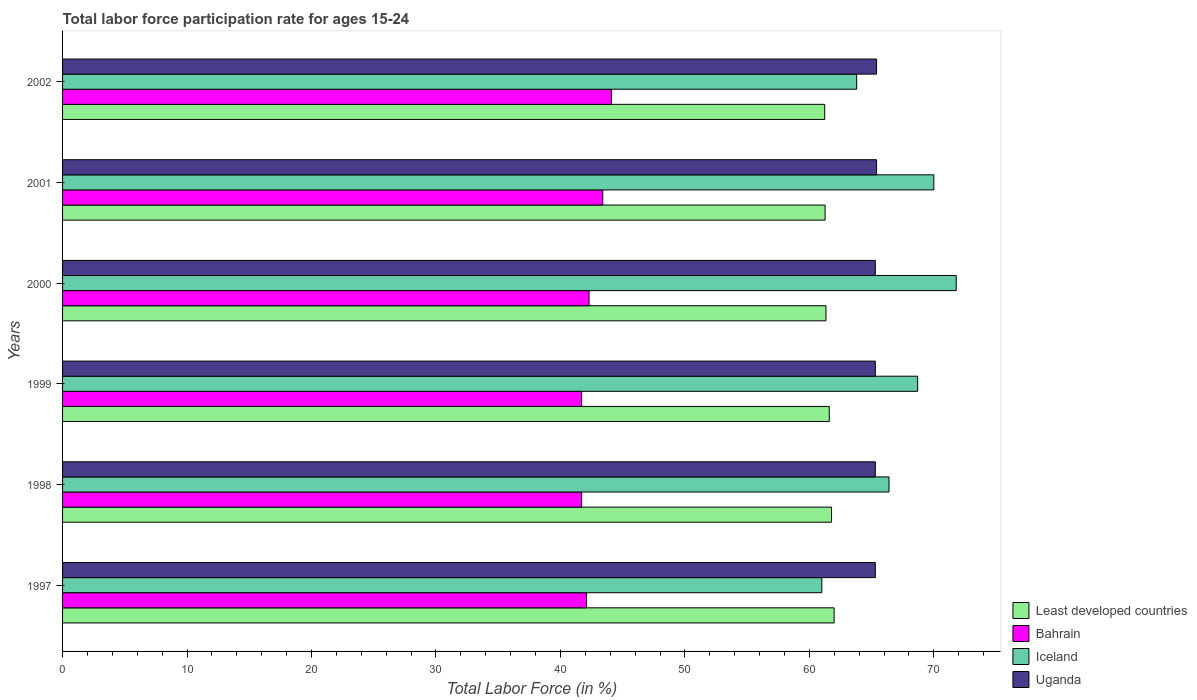How many different coloured bars are there?
Make the answer very short. 4. Are the number of bars on each tick of the Y-axis equal?
Provide a succinct answer. Yes. What is the label of the 4th group of bars from the top?
Give a very brief answer. 1999. What is the labor force participation rate in Iceland in 1999?
Your answer should be very brief. 68.7. Across all years, what is the maximum labor force participation rate in Uganda?
Ensure brevity in your answer.  65.4. Across all years, what is the minimum labor force participation rate in Iceland?
Your response must be concise. 61. In which year was the labor force participation rate in Iceland maximum?
Offer a very short reply. 2000. What is the total labor force participation rate in Iceland in the graph?
Ensure brevity in your answer.  401.7. What is the difference between the labor force participation rate in Least developed countries in 1998 and that in 1999?
Your answer should be compact. 0.18. What is the difference between the labor force participation rate in Iceland in 1997 and the labor force participation rate in Bahrain in 1999?
Offer a very short reply. 19.3. What is the average labor force participation rate in Least developed countries per year?
Provide a succinct answer. 61.53. In the year 2000, what is the difference between the labor force participation rate in Uganda and labor force participation rate in Bahrain?
Offer a terse response. 23. What is the ratio of the labor force participation rate in Iceland in 2001 to that in 2002?
Make the answer very short. 1.1. Is the difference between the labor force participation rate in Uganda in 1999 and 2000 greater than the difference between the labor force participation rate in Bahrain in 1999 and 2000?
Make the answer very short. Yes. What is the difference between the highest and the second highest labor force participation rate in Bahrain?
Offer a terse response. 0.7. What is the difference between the highest and the lowest labor force participation rate in Least developed countries?
Keep it short and to the point. 0.76. Is the sum of the labor force participation rate in Uganda in 2000 and 2002 greater than the maximum labor force participation rate in Iceland across all years?
Provide a succinct answer. Yes. Is it the case that in every year, the sum of the labor force participation rate in Iceland and labor force participation rate in Uganda is greater than the sum of labor force participation rate in Bahrain and labor force participation rate in Least developed countries?
Make the answer very short. Yes. What does the 3rd bar from the top in 2001 represents?
Ensure brevity in your answer.  Bahrain. What does the 4th bar from the bottom in 1999 represents?
Keep it short and to the point. Uganda. How many bars are there?
Offer a very short reply. 24. What is the difference between two consecutive major ticks on the X-axis?
Offer a very short reply. 10. Does the graph contain any zero values?
Offer a terse response. No. Where does the legend appear in the graph?
Make the answer very short. Bottom right. How many legend labels are there?
Make the answer very short. 4. What is the title of the graph?
Make the answer very short. Total labor force participation rate for ages 15-24. Does "Nepal" appear as one of the legend labels in the graph?
Ensure brevity in your answer.  No. What is the label or title of the X-axis?
Provide a short and direct response. Total Labor Force (in %). What is the Total Labor Force (in %) of Least developed countries in 1997?
Make the answer very short. 61.99. What is the Total Labor Force (in %) of Bahrain in 1997?
Offer a terse response. 42.1. What is the Total Labor Force (in %) of Iceland in 1997?
Your answer should be compact. 61. What is the Total Labor Force (in %) in Uganda in 1997?
Give a very brief answer. 65.3. What is the Total Labor Force (in %) in Least developed countries in 1998?
Your answer should be very brief. 61.78. What is the Total Labor Force (in %) in Bahrain in 1998?
Ensure brevity in your answer.  41.7. What is the Total Labor Force (in %) in Iceland in 1998?
Give a very brief answer. 66.4. What is the Total Labor Force (in %) of Uganda in 1998?
Offer a very short reply. 65.3. What is the Total Labor Force (in %) in Least developed countries in 1999?
Offer a very short reply. 61.6. What is the Total Labor Force (in %) of Bahrain in 1999?
Your answer should be very brief. 41.7. What is the Total Labor Force (in %) in Iceland in 1999?
Provide a short and direct response. 68.7. What is the Total Labor Force (in %) of Uganda in 1999?
Your response must be concise. 65.3. What is the Total Labor Force (in %) in Least developed countries in 2000?
Your answer should be compact. 61.33. What is the Total Labor Force (in %) of Bahrain in 2000?
Your response must be concise. 42.3. What is the Total Labor Force (in %) of Iceland in 2000?
Ensure brevity in your answer.  71.8. What is the Total Labor Force (in %) of Uganda in 2000?
Provide a succinct answer. 65.3. What is the Total Labor Force (in %) of Least developed countries in 2001?
Provide a succinct answer. 61.26. What is the Total Labor Force (in %) of Bahrain in 2001?
Offer a very short reply. 43.4. What is the Total Labor Force (in %) of Uganda in 2001?
Provide a succinct answer. 65.4. What is the Total Labor Force (in %) of Least developed countries in 2002?
Your answer should be compact. 61.23. What is the Total Labor Force (in %) of Bahrain in 2002?
Give a very brief answer. 44.1. What is the Total Labor Force (in %) in Iceland in 2002?
Give a very brief answer. 63.8. What is the Total Labor Force (in %) in Uganda in 2002?
Make the answer very short. 65.4. Across all years, what is the maximum Total Labor Force (in %) of Least developed countries?
Your response must be concise. 61.99. Across all years, what is the maximum Total Labor Force (in %) in Bahrain?
Provide a short and direct response. 44.1. Across all years, what is the maximum Total Labor Force (in %) of Iceland?
Provide a short and direct response. 71.8. Across all years, what is the maximum Total Labor Force (in %) of Uganda?
Give a very brief answer. 65.4. Across all years, what is the minimum Total Labor Force (in %) of Least developed countries?
Offer a terse response. 61.23. Across all years, what is the minimum Total Labor Force (in %) in Bahrain?
Give a very brief answer. 41.7. Across all years, what is the minimum Total Labor Force (in %) of Iceland?
Offer a terse response. 61. Across all years, what is the minimum Total Labor Force (in %) in Uganda?
Provide a succinct answer. 65.3. What is the total Total Labor Force (in %) of Least developed countries in the graph?
Ensure brevity in your answer.  369.2. What is the total Total Labor Force (in %) in Bahrain in the graph?
Provide a short and direct response. 255.3. What is the total Total Labor Force (in %) of Iceland in the graph?
Offer a very short reply. 401.7. What is the total Total Labor Force (in %) in Uganda in the graph?
Offer a very short reply. 392. What is the difference between the Total Labor Force (in %) of Least developed countries in 1997 and that in 1998?
Keep it short and to the point. 0.21. What is the difference between the Total Labor Force (in %) in Iceland in 1997 and that in 1998?
Provide a short and direct response. -5.4. What is the difference between the Total Labor Force (in %) in Uganda in 1997 and that in 1998?
Offer a terse response. 0. What is the difference between the Total Labor Force (in %) in Least developed countries in 1997 and that in 1999?
Provide a short and direct response. 0.39. What is the difference between the Total Labor Force (in %) of Least developed countries in 1997 and that in 2000?
Your response must be concise. 0.66. What is the difference between the Total Labor Force (in %) of Bahrain in 1997 and that in 2000?
Keep it short and to the point. -0.2. What is the difference between the Total Labor Force (in %) in Uganda in 1997 and that in 2000?
Make the answer very short. 0. What is the difference between the Total Labor Force (in %) in Least developed countries in 1997 and that in 2001?
Keep it short and to the point. 0.73. What is the difference between the Total Labor Force (in %) of Bahrain in 1997 and that in 2001?
Offer a very short reply. -1.3. What is the difference between the Total Labor Force (in %) in Least developed countries in 1997 and that in 2002?
Offer a terse response. 0.76. What is the difference between the Total Labor Force (in %) in Least developed countries in 1998 and that in 1999?
Your response must be concise. 0.18. What is the difference between the Total Labor Force (in %) in Bahrain in 1998 and that in 1999?
Keep it short and to the point. 0. What is the difference between the Total Labor Force (in %) of Iceland in 1998 and that in 1999?
Give a very brief answer. -2.3. What is the difference between the Total Labor Force (in %) in Uganda in 1998 and that in 1999?
Give a very brief answer. 0. What is the difference between the Total Labor Force (in %) in Least developed countries in 1998 and that in 2000?
Your answer should be very brief. 0.45. What is the difference between the Total Labor Force (in %) of Iceland in 1998 and that in 2000?
Give a very brief answer. -5.4. What is the difference between the Total Labor Force (in %) in Least developed countries in 1998 and that in 2001?
Provide a succinct answer. 0.52. What is the difference between the Total Labor Force (in %) of Iceland in 1998 and that in 2001?
Provide a succinct answer. -3.6. What is the difference between the Total Labor Force (in %) in Least developed countries in 1998 and that in 2002?
Provide a succinct answer. 0.55. What is the difference between the Total Labor Force (in %) in Bahrain in 1998 and that in 2002?
Give a very brief answer. -2.4. What is the difference between the Total Labor Force (in %) of Iceland in 1998 and that in 2002?
Your answer should be very brief. 2.6. What is the difference between the Total Labor Force (in %) of Least developed countries in 1999 and that in 2000?
Offer a terse response. 0.27. What is the difference between the Total Labor Force (in %) of Bahrain in 1999 and that in 2000?
Give a very brief answer. -0.6. What is the difference between the Total Labor Force (in %) in Iceland in 1999 and that in 2000?
Offer a very short reply. -3.1. What is the difference between the Total Labor Force (in %) of Uganda in 1999 and that in 2000?
Offer a terse response. 0. What is the difference between the Total Labor Force (in %) in Least developed countries in 1999 and that in 2001?
Your answer should be very brief. 0.34. What is the difference between the Total Labor Force (in %) of Bahrain in 1999 and that in 2001?
Keep it short and to the point. -1.7. What is the difference between the Total Labor Force (in %) of Iceland in 1999 and that in 2001?
Ensure brevity in your answer.  -1.3. What is the difference between the Total Labor Force (in %) of Least developed countries in 1999 and that in 2002?
Keep it short and to the point. 0.37. What is the difference between the Total Labor Force (in %) in Iceland in 1999 and that in 2002?
Your answer should be very brief. 4.9. What is the difference between the Total Labor Force (in %) in Least developed countries in 2000 and that in 2001?
Make the answer very short. 0.07. What is the difference between the Total Labor Force (in %) in Uganda in 2000 and that in 2001?
Your answer should be very brief. -0.1. What is the difference between the Total Labor Force (in %) in Least developed countries in 2000 and that in 2002?
Keep it short and to the point. 0.1. What is the difference between the Total Labor Force (in %) of Bahrain in 2000 and that in 2002?
Keep it short and to the point. -1.8. What is the difference between the Total Labor Force (in %) in Uganda in 2000 and that in 2002?
Make the answer very short. -0.1. What is the difference between the Total Labor Force (in %) in Least developed countries in 2001 and that in 2002?
Ensure brevity in your answer.  0.03. What is the difference between the Total Labor Force (in %) of Bahrain in 2001 and that in 2002?
Provide a short and direct response. -0.7. What is the difference between the Total Labor Force (in %) of Least developed countries in 1997 and the Total Labor Force (in %) of Bahrain in 1998?
Give a very brief answer. 20.29. What is the difference between the Total Labor Force (in %) in Least developed countries in 1997 and the Total Labor Force (in %) in Iceland in 1998?
Offer a very short reply. -4.41. What is the difference between the Total Labor Force (in %) in Least developed countries in 1997 and the Total Labor Force (in %) in Uganda in 1998?
Offer a terse response. -3.31. What is the difference between the Total Labor Force (in %) in Bahrain in 1997 and the Total Labor Force (in %) in Iceland in 1998?
Keep it short and to the point. -24.3. What is the difference between the Total Labor Force (in %) of Bahrain in 1997 and the Total Labor Force (in %) of Uganda in 1998?
Give a very brief answer. -23.2. What is the difference between the Total Labor Force (in %) in Least developed countries in 1997 and the Total Labor Force (in %) in Bahrain in 1999?
Offer a very short reply. 20.29. What is the difference between the Total Labor Force (in %) in Least developed countries in 1997 and the Total Labor Force (in %) in Iceland in 1999?
Make the answer very short. -6.71. What is the difference between the Total Labor Force (in %) in Least developed countries in 1997 and the Total Labor Force (in %) in Uganda in 1999?
Provide a succinct answer. -3.31. What is the difference between the Total Labor Force (in %) of Bahrain in 1997 and the Total Labor Force (in %) of Iceland in 1999?
Your answer should be compact. -26.6. What is the difference between the Total Labor Force (in %) of Bahrain in 1997 and the Total Labor Force (in %) of Uganda in 1999?
Provide a short and direct response. -23.2. What is the difference between the Total Labor Force (in %) of Iceland in 1997 and the Total Labor Force (in %) of Uganda in 1999?
Provide a short and direct response. -4.3. What is the difference between the Total Labor Force (in %) in Least developed countries in 1997 and the Total Labor Force (in %) in Bahrain in 2000?
Offer a terse response. 19.69. What is the difference between the Total Labor Force (in %) of Least developed countries in 1997 and the Total Labor Force (in %) of Iceland in 2000?
Your answer should be very brief. -9.81. What is the difference between the Total Labor Force (in %) of Least developed countries in 1997 and the Total Labor Force (in %) of Uganda in 2000?
Ensure brevity in your answer.  -3.31. What is the difference between the Total Labor Force (in %) of Bahrain in 1997 and the Total Labor Force (in %) of Iceland in 2000?
Offer a very short reply. -29.7. What is the difference between the Total Labor Force (in %) in Bahrain in 1997 and the Total Labor Force (in %) in Uganda in 2000?
Your response must be concise. -23.2. What is the difference between the Total Labor Force (in %) of Least developed countries in 1997 and the Total Labor Force (in %) of Bahrain in 2001?
Offer a very short reply. 18.59. What is the difference between the Total Labor Force (in %) in Least developed countries in 1997 and the Total Labor Force (in %) in Iceland in 2001?
Your answer should be very brief. -8.01. What is the difference between the Total Labor Force (in %) of Least developed countries in 1997 and the Total Labor Force (in %) of Uganda in 2001?
Your answer should be compact. -3.41. What is the difference between the Total Labor Force (in %) in Bahrain in 1997 and the Total Labor Force (in %) in Iceland in 2001?
Your answer should be very brief. -27.9. What is the difference between the Total Labor Force (in %) in Bahrain in 1997 and the Total Labor Force (in %) in Uganda in 2001?
Give a very brief answer. -23.3. What is the difference between the Total Labor Force (in %) in Least developed countries in 1997 and the Total Labor Force (in %) in Bahrain in 2002?
Provide a succinct answer. 17.89. What is the difference between the Total Labor Force (in %) of Least developed countries in 1997 and the Total Labor Force (in %) of Iceland in 2002?
Provide a short and direct response. -1.81. What is the difference between the Total Labor Force (in %) in Least developed countries in 1997 and the Total Labor Force (in %) in Uganda in 2002?
Ensure brevity in your answer.  -3.41. What is the difference between the Total Labor Force (in %) in Bahrain in 1997 and the Total Labor Force (in %) in Iceland in 2002?
Your answer should be compact. -21.7. What is the difference between the Total Labor Force (in %) in Bahrain in 1997 and the Total Labor Force (in %) in Uganda in 2002?
Provide a short and direct response. -23.3. What is the difference between the Total Labor Force (in %) in Iceland in 1997 and the Total Labor Force (in %) in Uganda in 2002?
Offer a terse response. -4.4. What is the difference between the Total Labor Force (in %) of Least developed countries in 1998 and the Total Labor Force (in %) of Bahrain in 1999?
Ensure brevity in your answer.  20.08. What is the difference between the Total Labor Force (in %) in Least developed countries in 1998 and the Total Labor Force (in %) in Iceland in 1999?
Make the answer very short. -6.92. What is the difference between the Total Labor Force (in %) in Least developed countries in 1998 and the Total Labor Force (in %) in Uganda in 1999?
Make the answer very short. -3.52. What is the difference between the Total Labor Force (in %) of Bahrain in 1998 and the Total Labor Force (in %) of Iceland in 1999?
Ensure brevity in your answer.  -27. What is the difference between the Total Labor Force (in %) in Bahrain in 1998 and the Total Labor Force (in %) in Uganda in 1999?
Provide a short and direct response. -23.6. What is the difference between the Total Labor Force (in %) in Least developed countries in 1998 and the Total Labor Force (in %) in Bahrain in 2000?
Provide a short and direct response. 19.48. What is the difference between the Total Labor Force (in %) in Least developed countries in 1998 and the Total Labor Force (in %) in Iceland in 2000?
Your answer should be compact. -10.02. What is the difference between the Total Labor Force (in %) in Least developed countries in 1998 and the Total Labor Force (in %) in Uganda in 2000?
Your answer should be very brief. -3.52. What is the difference between the Total Labor Force (in %) in Bahrain in 1998 and the Total Labor Force (in %) in Iceland in 2000?
Offer a terse response. -30.1. What is the difference between the Total Labor Force (in %) of Bahrain in 1998 and the Total Labor Force (in %) of Uganda in 2000?
Provide a short and direct response. -23.6. What is the difference between the Total Labor Force (in %) in Least developed countries in 1998 and the Total Labor Force (in %) in Bahrain in 2001?
Your response must be concise. 18.38. What is the difference between the Total Labor Force (in %) in Least developed countries in 1998 and the Total Labor Force (in %) in Iceland in 2001?
Provide a short and direct response. -8.22. What is the difference between the Total Labor Force (in %) in Least developed countries in 1998 and the Total Labor Force (in %) in Uganda in 2001?
Offer a very short reply. -3.62. What is the difference between the Total Labor Force (in %) of Bahrain in 1998 and the Total Labor Force (in %) of Iceland in 2001?
Make the answer very short. -28.3. What is the difference between the Total Labor Force (in %) of Bahrain in 1998 and the Total Labor Force (in %) of Uganda in 2001?
Offer a terse response. -23.7. What is the difference between the Total Labor Force (in %) in Iceland in 1998 and the Total Labor Force (in %) in Uganda in 2001?
Keep it short and to the point. 1. What is the difference between the Total Labor Force (in %) of Least developed countries in 1998 and the Total Labor Force (in %) of Bahrain in 2002?
Give a very brief answer. 17.68. What is the difference between the Total Labor Force (in %) in Least developed countries in 1998 and the Total Labor Force (in %) in Iceland in 2002?
Give a very brief answer. -2.02. What is the difference between the Total Labor Force (in %) in Least developed countries in 1998 and the Total Labor Force (in %) in Uganda in 2002?
Your response must be concise. -3.62. What is the difference between the Total Labor Force (in %) in Bahrain in 1998 and the Total Labor Force (in %) in Iceland in 2002?
Your answer should be compact. -22.1. What is the difference between the Total Labor Force (in %) in Bahrain in 1998 and the Total Labor Force (in %) in Uganda in 2002?
Keep it short and to the point. -23.7. What is the difference between the Total Labor Force (in %) in Iceland in 1998 and the Total Labor Force (in %) in Uganda in 2002?
Make the answer very short. 1. What is the difference between the Total Labor Force (in %) in Least developed countries in 1999 and the Total Labor Force (in %) in Bahrain in 2000?
Give a very brief answer. 19.3. What is the difference between the Total Labor Force (in %) in Least developed countries in 1999 and the Total Labor Force (in %) in Iceland in 2000?
Provide a succinct answer. -10.2. What is the difference between the Total Labor Force (in %) in Least developed countries in 1999 and the Total Labor Force (in %) in Uganda in 2000?
Offer a terse response. -3.7. What is the difference between the Total Labor Force (in %) of Bahrain in 1999 and the Total Labor Force (in %) of Iceland in 2000?
Provide a short and direct response. -30.1. What is the difference between the Total Labor Force (in %) in Bahrain in 1999 and the Total Labor Force (in %) in Uganda in 2000?
Make the answer very short. -23.6. What is the difference between the Total Labor Force (in %) in Iceland in 1999 and the Total Labor Force (in %) in Uganda in 2000?
Your response must be concise. 3.4. What is the difference between the Total Labor Force (in %) of Least developed countries in 1999 and the Total Labor Force (in %) of Bahrain in 2001?
Keep it short and to the point. 18.2. What is the difference between the Total Labor Force (in %) in Least developed countries in 1999 and the Total Labor Force (in %) in Iceland in 2001?
Your answer should be very brief. -8.4. What is the difference between the Total Labor Force (in %) in Least developed countries in 1999 and the Total Labor Force (in %) in Uganda in 2001?
Ensure brevity in your answer.  -3.8. What is the difference between the Total Labor Force (in %) in Bahrain in 1999 and the Total Labor Force (in %) in Iceland in 2001?
Offer a very short reply. -28.3. What is the difference between the Total Labor Force (in %) of Bahrain in 1999 and the Total Labor Force (in %) of Uganda in 2001?
Ensure brevity in your answer.  -23.7. What is the difference between the Total Labor Force (in %) of Least developed countries in 1999 and the Total Labor Force (in %) of Bahrain in 2002?
Your answer should be compact. 17.5. What is the difference between the Total Labor Force (in %) of Least developed countries in 1999 and the Total Labor Force (in %) of Iceland in 2002?
Your response must be concise. -2.2. What is the difference between the Total Labor Force (in %) of Least developed countries in 1999 and the Total Labor Force (in %) of Uganda in 2002?
Your answer should be very brief. -3.8. What is the difference between the Total Labor Force (in %) in Bahrain in 1999 and the Total Labor Force (in %) in Iceland in 2002?
Offer a terse response. -22.1. What is the difference between the Total Labor Force (in %) of Bahrain in 1999 and the Total Labor Force (in %) of Uganda in 2002?
Your response must be concise. -23.7. What is the difference between the Total Labor Force (in %) of Least developed countries in 2000 and the Total Labor Force (in %) of Bahrain in 2001?
Ensure brevity in your answer.  17.93. What is the difference between the Total Labor Force (in %) in Least developed countries in 2000 and the Total Labor Force (in %) in Iceland in 2001?
Your response must be concise. -8.67. What is the difference between the Total Labor Force (in %) in Least developed countries in 2000 and the Total Labor Force (in %) in Uganda in 2001?
Your answer should be compact. -4.07. What is the difference between the Total Labor Force (in %) of Bahrain in 2000 and the Total Labor Force (in %) of Iceland in 2001?
Provide a succinct answer. -27.7. What is the difference between the Total Labor Force (in %) of Bahrain in 2000 and the Total Labor Force (in %) of Uganda in 2001?
Provide a short and direct response. -23.1. What is the difference between the Total Labor Force (in %) of Iceland in 2000 and the Total Labor Force (in %) of Uganda in 2001?
Your answer should be very brief. 6.4. What is the difference between the Total Labor Force (in %) in Least developed countries in 2000 and the Total Labor Force (in %) in Bahrain in 2002?
Your answer should be very brief. 17.23. What is the difference between the Total Labor Force (in %) of Least developed countries in 2000 and the Total Labor Force (in %) of Iceland in 2002?
Offer a terse response. -2.47. What is the difference between the Total Labor Force (in %) of Least developed countries in 2000 and the Total Labor Force (in %) of Uganda in 2002?
Provide a succinct answer. -4.07. What is the difference between the Total Labor Force (in %) of Bahrain in 2000 and the Total Labor Force (in %) of Iceland in 2002?
Keep it short and to the point. -21.5. What is the difference between the Total Labor Force (in %) of Bahrain in 2000 and the Total Labor Force (in %) of Uganda in 2002?
Your answer should be very brief. -23.1. What is the difference between the Total Labor Force (in %) of Iceland in 2000 and the Total Labor Force (in %) of Uganda in 2002?
Give a very brief answer. 6.4. What is the difference between the Total Labor Force (in %) of Least developed countries in 2001 and the Total Labor Force (in %) of Bahrain in 2002?
Give a very brief answer. 17.16. What is the difference between the Total Labor Force (in %) of Least developed countries in 2001 and the Total Labor Force (in %) of Iceland in 2002?
Ensure brevity in your answer.  -2.54. What is the difference between the Total Labor Force (in %) of Least developed countries in 2001 and the Total Labor Force (in %) of Uganda in 2002?
Make the answer very short. -4.14. What is the difference between the Total Labor Force (in %) of Bahrain in 2001 and the Total Labor Force (in %) of Iceland in 2002?
Keep it short and to the point. -20.4. What is the difference between the Total Labor Force (in %) of Bahrain in 2001 and the Total Labor Force (in %) of Uganda in 2002?
Ensure brevity in your answer.  -22. What is the difference between the Total Labor Force (in %) of Iceland in 2001 and the Total Labor Force (in %) of Uganda in 2002?
Your response must be concise. 4.6. What is the average Total Labor Force (in %) of Least developed countries per year?
Offer a terse response. 61.53. What is the average Total Labor Force (in %) in Bahrain per year?
Keep it short and to the point. 42.55. What is the average Total Labor Force (in %) of Iceland per year?
Ensure brevity in your answer.  66.95. What is the average Total Labor Force (in %) of Uganda per year?
Your response must be concise. 65.33. In the year 1997, what is the difference between the Total Labor Force (in %) of Least developed countries and Total Labor Force (in %) of Bahrain?
Ensure brevity in your answer.  19.89. In the year 1997, what is the difference between the Total Labor Force (in %) of Least developed countries and Total Labor Force (in %) of Iceland?
Ensure brevity in your answer.  0.99. In the year 1997, what is the difference between the Total Labor Force (in %) of Least developed countries and Total Labor Force (in %) of Uganda?
Provide a short and direct response. -3.31. In the year 1997, what is the difference between the Total Labor Force (in %) in Bahrain and Total Labor Force (in %) in Iceland?
Your response must be concise. -18.9. In the year 1997, what is the difference between the Total Labor Force (in %) of Bahrain and Total Labor Force (in %) of Uganda?
Keep it short and to the point. -23.2. In the year 1997, what is the difference between the Total Labor Force (in %) of Iceland and Total Labor Force (in %) of Uganda?
Your response must be concise. -4.3. In the year 1998, what is the difference between the Total Labor Force (in %) in Least developed countries and Total Labor Force (in %) in Bahrain?
Make the answer very short. 20.08. In the year 1998, what is the difference between the Total Labor Force (in %) of Least developed countries and Total Labor Force (in %) of Iceland?
Give a very brief answer. -4.62. In the year 1998, what is the difference between the Total Labor Force (in %) in Least developed countries and Total Labor Force (in %) in Uganda?
Keep it short and to the point. -3.52. In the year 1998, what is the difference between the Total Labor Force (in %) of Bahrain and Total Labor Force (in %) of Iceland?
Provide a short and direct response. -24.7. In the year 1998, what is the difference between the Total Labor Force (in %) in Bahrain and Total Labor Force (in %) in Uganda?
Offer a very short reply. -23.6. In the year 1998, what is the difference between the Total Labor Force (in %) in Iceland and Total Labor Force (in %) in Uganda?
Provide a succinct answer. 1.1. In the year 1999, what is the difference between the Total Labor Force (in %) in Least developed countries and Total Labor Force (in %) in Bahrain?
Keep it short and to the point. 19.9. In the year 1999, what is the difference between the Total Labor Force (in %) in Least developed countries and Total Labor Force (in %) in Iceland?
Your answer should be compact. -7.1. In the year 1999, what is the difference between the Total Labor Force (in %) in Least developed countries and Total Labor Force (in %) in Uganda?
Your response must be concise. -3.7. In the year 1999, what is the difference between the Total Labor Force (in %) in Bahrain and Total Labor Force (in %) in Uganda?
Offer a very short reply. -23.6. In the year 1999, what is the difference between the Total Labor Force (in %) in Iceland and Total Labor Force (in %) in Uganda?
Ensure brevity in your answer.  3.4. In the year 2000, what is the difference between the Total Labor Force (in %) in Least developed countries and Total Labor Force (in %) in Bahrain?
Make the answer very short. 19.03. In the year 2000, what is the difference between the Total Labor Force (in %) of Least developed countries and Total Labor Force (in %) of Iceland?
Ensure brevity in your answer.  -10.47. In the year 2000, what is the difference between the Total Labor Force (in %) of Least developed countries and Total Labor Force (in %) of Uganda?
Give a very brief answer. -3.97. In the year 2000, what is the difference between the Total Labor Force (in %) of Bahrain and Total Labor Force (in %) of Iceland?
Keep it short and to the point. -29.5. In the year 2000, what is the difference between the Total Labor Force (in %) of Bahrain and Total Labor Force (in %) of Uganda?
Keep it short and to the point. -23. In the year 2001, what is the difference between the Total Labor Force (in %) in Least developed countries and Total Labor Force (in %) in Bahrain?
Your answer should be very brief. 17.86. In the year 2001, what is the difference between the Total Labor Force (in %) in Least developed countries and Total Labor Force (in %) in Iceland?
Offer a terse response. -8.74. In the year 2001, what is the difference between the Total Labor Force (in %) of Least developed countries and Total Labor Force (in %) of Uganda?
Your response must be concise. -4.14. In the year 2001, what is the difference between the Total Labor Force (in %) of Bahrain and Total Labor Force (in %) of Iceland?
Keep it short and to the point. -26.6. In the year 2001, what is the difference between the Total Labor Force (in %) of Iceland and Total Labor Force (in %) of Uganda?
Offer a very short reply. 4.6. In the year 2002, what is the difference between the Total Labor Force (in %) in Least developed countries and Total Labor Force (in %) in Bahrain?
Offer a very short reply. 17.13. In the year 2002, what is the difference between the Total Labor Force (in %) of Least developed countries and Total Labor Force (in %) of Iceland?
Make the answer very short. -2.57. In the year 2002, what is the difference between the Total Labor Force (in %) in Least developed countries and Total Labor Force (in %) in Uganda?
Ensure brevity in your answer.  -4.17. In the year 2002, what is the difference between the Total Labor Force (in %) of Bahrain and Total Labor Force (in %) of Iceland?
Your answer should be very brief. -19.7. In the year 2002, what is the difference between the Total Labor Force (in %) in Bahrain and Total Labor Force (in %) in Uganda?
Offer a very short reply. -21.3. In the year 2002, what is the difference between the Total Labor Force (in %) of Iceland and Total Labor Force (in %) of Uganda?
Ensure brevity in your answer.  -1.6. What is the ratio of the Total Labor Force (in %) in Bahrain in 1997 to that in 1998?
Provide a short and direct response. 1.01. What is the ratio of the Total Labor Force (in %) of Iceland in 1997 to that in 1998?
Give a very brief answer. 0.92. What is the ratio of the Total Labor Force (in %) of Bahrain in 1997 to that in 1999?
Ensure brevity in your answer.  1.01. What is the ratio of the Total Labor Force (in %) in Iceland in 1997 to that in 1999?
Ensure brevity in your answer.  0.89. What is the ratio of the Total Labor Force (in %) in Least developed countries in 1997 to that in 2000?
Give a very brief answer. 1.01. What is the ratio of the Total Labor Force (in %) in Bahrain in 1997 to that in 2000?
Give a very brief answer. 1. What is the ratio of the Total Labor Force (in %) of Iceland in 1997 to that in 2000?
Provide a succinct answer. 0.85. What is the ratio of the Total Labor Force (in %) of Least developed countries in 1997 to that in 2001?
Your answer should be very brief. 1.01. What is the ratio of the Total Labor Force (in %) of Bahrain in 1997 to that in 2001?
Offer a terse response. 0.97. What is the ratio of the Total Labor Force (in %) of Iceland in 1997 to that in 2001?
Offer a terse response. 0.87. What is the ratio of the Total Labor Force (in %) of Least developed countries in 1997 to that in 2002?
Your response must be concise. 1.01. What is the ratio of the Total Labor Force (in %) of Bahrain in 1997 to that in 2002?
Keep it short and to the point. 0.95. What is the ratio of the Total Labor Force (in %) of Iceland in 1997 to that in 2002?
Make the answer very short. 0.96. What is the ratio of the Total Labor Force (in %) of Uganda in 1997 to that in 2002?
Ensure brevity in your answer.  1. What is the ratio of the Total Labor Force (in %) of Least developed countries in 1998 to that in 1999?
Offer a terse response. 1. What is the ratio of the Total Labor Force (in %) in Bahrain in 1998 to that in 1999?
Offer a very short reply. 1. What is the ratio of the Total Labor Force (in %) in Iceland in 1998 to that in 1999?
Your response must be concise. 0.97. What is the ratio of the Total Labor Force (in %) of Least developed countries in 1998 to that in 2000?
Provide a succinct answer. 1.01. What is the ratio of the Total Labor Force (in %) in Bahrain in 1998 to that in 2000?
Offer a terse response. 0.99. What is the ratio of the Total Labor Force (in %) in Iceland in 1998 to that in 2000?
Your answer should be compact. 0.92. What is the ratio of the Total Labor Force (in %) of Least developed countries in 1998 to that in 2001?
Keep it short and to the point. 1.01. What is the ratio of the Total Labor Force (in %) in Bahrain in 1998 to that in 2001?
Ensure brevity in your answer.  0.96. What is the ratio of the Total Labor Force (in %) in Iceland in 1998 to that in 2001?
Your answer should be very brief. 0.95. What is the ratio of the Total Labor Force (in %) in Uganda in 1998 to that in 2001?
Your answer should be very brief. 1. What is the ratio of the Total Labor Force (in %) of Bahrain in 1998 to that in 2002?
Offer a terse response. 0.95. What is the ratio of the Total Labor Force (in %) in Iceland in 1998 to that in 2002?
Offer a very short reply. 1.04. What is the ratio of the Total Labor Force (in %) in Uganda in 1998 to that in 2002?
Make the answer very short. 1. What is the ratio of the Total Labor Force (in %) in Bahrain in 1999 to that in 2000?
Give a very brief answer. 0.99. What is the ratio of the Total Labor Force (in %) in Iceland in 1999 to that in 2000?
Your answer should be compact. 0.96. What is the ratio of the Total Labor Force (in %) of Bahrain in 1999 to that in 2001?
Make the answer very short. 0.96. What is the ratio of the Total Labor Force (in %) of Iceland in 1999 to that in 2001?
Offer a terse response. 0.98. What is the ratio of the Total Labor Force (in %) in Bahrain in 1999 to that in 2002?
Your answer should be very brief. 0.95. What is the ratio of the Total Labor Force (in %) in Iceland in 1999 to that in 2002?
Give a very brief answer. 1.08. What is the ratio of the Total Labor Force (in %) in Least developed countries in 2000 to that in 2001?
Make the answer very short. 1. What is the ratio of the Total Labor Force (in %) in Bahrain in 2000 to that in 2001?
Offer a terse response. 0.97. What is the ratio of the Total Labor Force (in %) in Iceland in 2000 to that in 2001?
Give a very brief answer. 1.03. What is the ratio of the Total Labor Force (in %) of Least developed countries in 2000 to that in 2002?
Offer a very short reply. 1. What is the ratio of the Total Labor Force (in %) of Bahrain in 2000 to that in 2002?
Ensure brevity in your answer.  0.96. What is the ratio of the Total Labor Force (in %) in Iceland in 2000 to that in 2002?
Provide a succinct answer. 1.13. What is the ratio of the Total Labor Force (in %) of Uganda in 2000 to that in 2002?
Make the answer very short. 1. What is the ratio of the Total Labor Force (in %) in Least developed countries in 2001 to that in 2002?
Keep it short and to the point. 1. What is the ratio of the Total Labor Force (in %) of Bahrain in 2001 to that in 2002?
Give a very brief answer. 0.98. What is the ratio of the Total Labor Force (in %) of Iceland in 2001 to that in 2002?
Offer a very short reply. 1.1. What is the difference between the highest and the second highest Total Labor Force (in %) of Least developed countries?
Your answer should be compact. 0.21. What is the difference between the highest and the lowest Total Labor Force (in %) of Least developed countries?
Keep it short and to the point. 0.76. What is the difference between the highest and the lowest Total Labor Force (in %) of Iceland?
Offer a terse response. 10.8. 